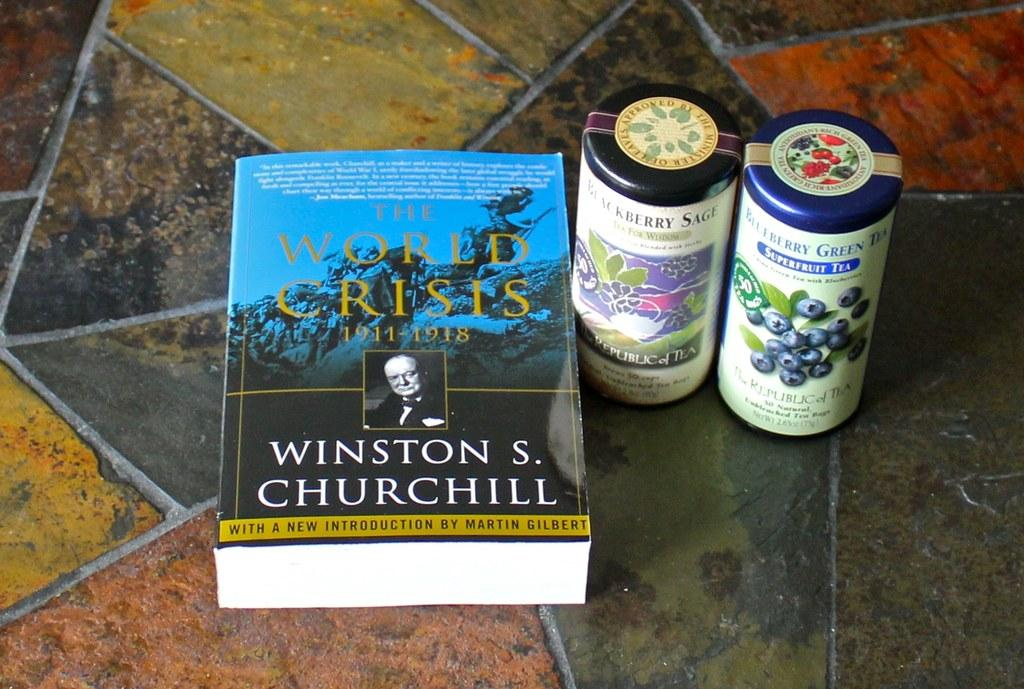What is on the floor in the image? There is a book and two bottles on the floor. Can you describe the book in the image? The book is on the floor, but there is no information about its title, author, or content. How many bottles are on the floor? There are two bottles on the floor. What is the book's opinion on the drum in the image? There is no drum present in the image, so the book cannot have an opinion on it. 